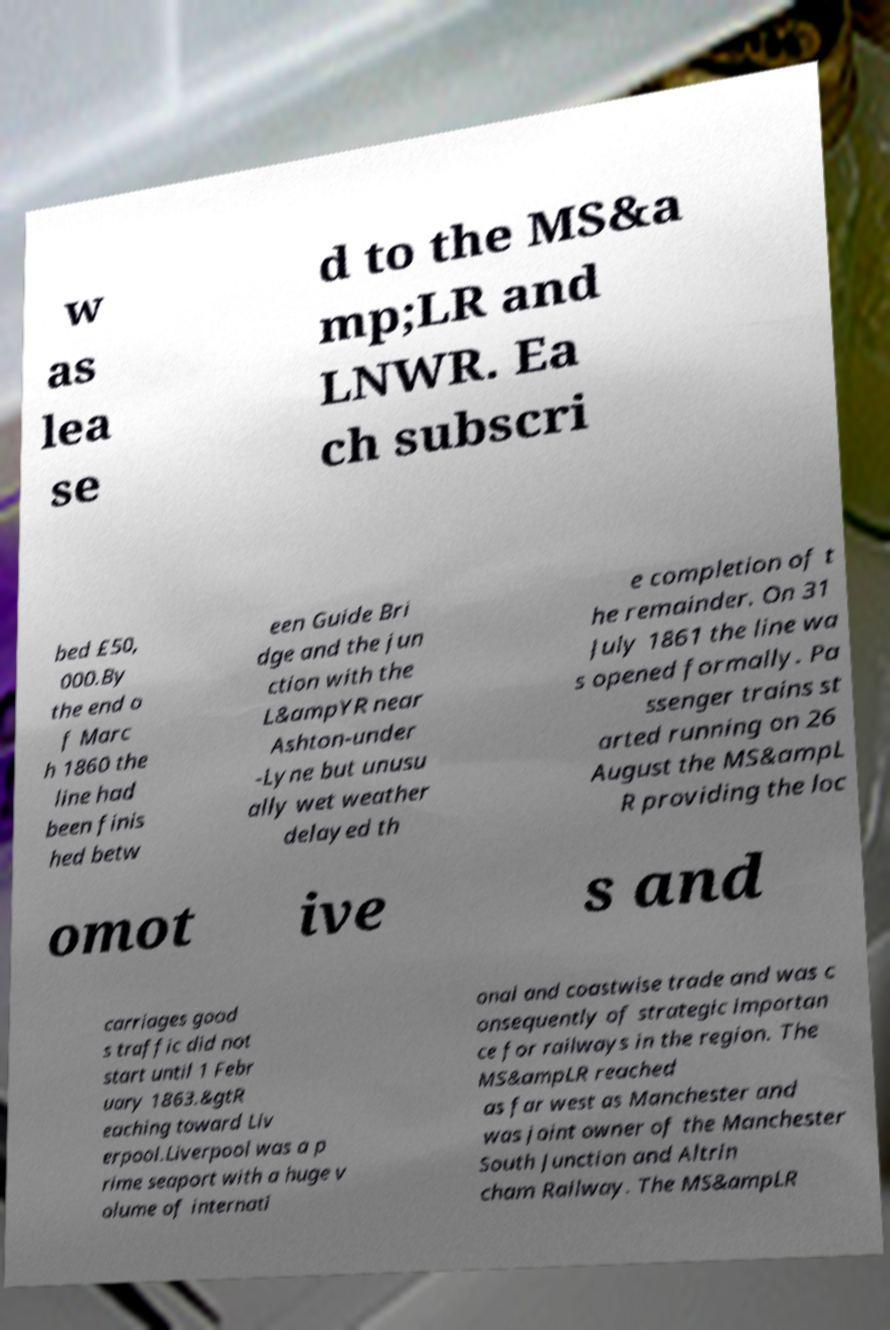Can you read and provide the text displayed in the image?This photo seems to have some interesting text. Can you extract and type it out for me? w as lea se d to the MS&a mp;LR and LNWR. Ea ch subscri bed £50, 000.By the end o f Marc h 1860 the line had been finis hed betw een Guide Bri dge and the jun ction with the L&ampYR near Ashton-under -Lyne but unusu ally wet weather delayed th e completion of t he remainder. On 31 July 1861 the line wa s opened formally. Pa ssenger trains st arted running on 26 August the MS&ampL R providing the loc omot ive s and carriages good s traffic did not start until 1 Febr uary 1863.&gtR eaching toward Liv erpool.Liverpool was a p rime seaport with a huge v olume of internati onal and coastwise trade and was c onsequently of strategic importan ce for railways in the region. The MS&ampLR reached as far west as Manchester and was joint owner of the Manchester South Junction and Altrin cham Railway. The MS&ampLR 